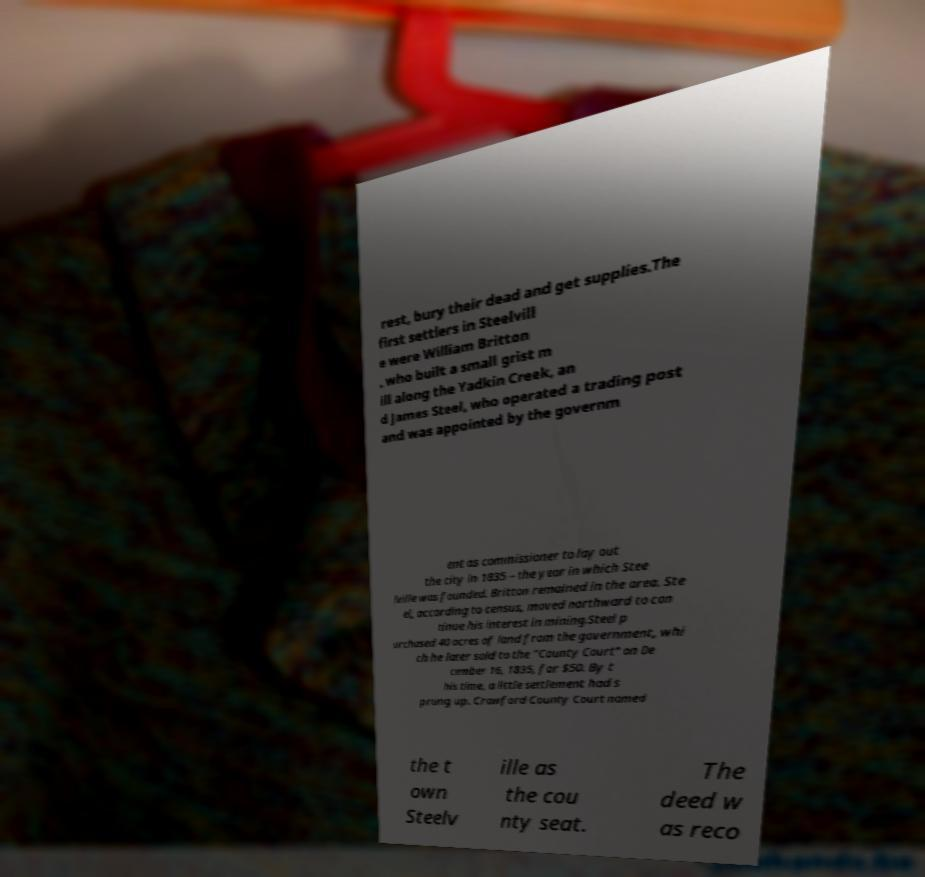Can you accurately transcribe the text from the provided image for me? rest, bury their dead and get supplies.The first settlers in Steelvill e were William Britton , who built a small grist m ill along the Yadkin Creek, an d James Steel, who operated a trading post and was appointed by the governm ent as commissioner to lay out the city in 1835 – the year in which Stee lville was founded. Britton remained in the area. Ste el, according to census, moved northward to con tinue his interest in mining.Steel p urchased 40 acres of land from the government, whi ch he later sold to the "County Court" on De cember 16, 1835, for $50. By t his time, a little settlement had s prung up. Crawford County Court named the t own Steelv ille as the cou nty seat. The deed w as reco 